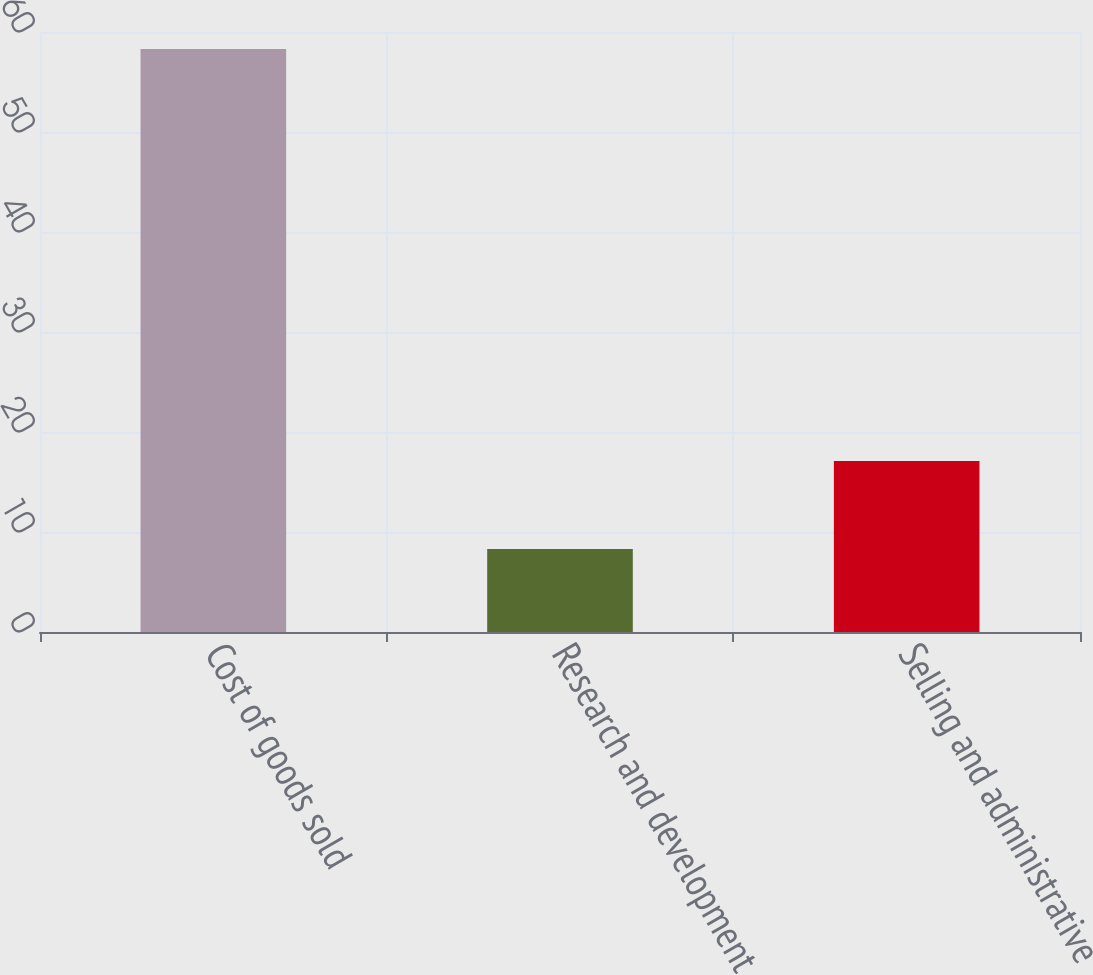Convert chart. <chart><loc_0><loc_0><loc_500><loc_500><bar_chart><fcel>Cost of goods sold<fcel>Research and development<fcel>Selling and administrative<nl><fcel>58.3<fcel>8.3<fcel>17.1<nl></chart> 